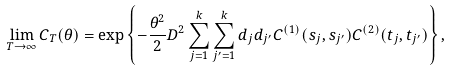Convert formula to latex. <formula><loc_0><loc_0><loc_500><loc_500>& \lim _ { T \to \infty } C _ { T } ( \theta ) = \exp \left \{ - \frac { \theta ^ { 2 } } { 2 } D ^ { 2 } \sum _ { j = 1 } ^ { k } \sum _ { j ^ { \prime } = 1 } ^ { k } d _ { j } d _ { j ^ { \prime } } C ^ { ( 1 ) } ( s _ { j } , s _ { j ^ { \prime } } ) C ^ { ( 2 ) } ( t _ { j } , t _ { j ^ { \prime } } ) \right \} ,</formula> 